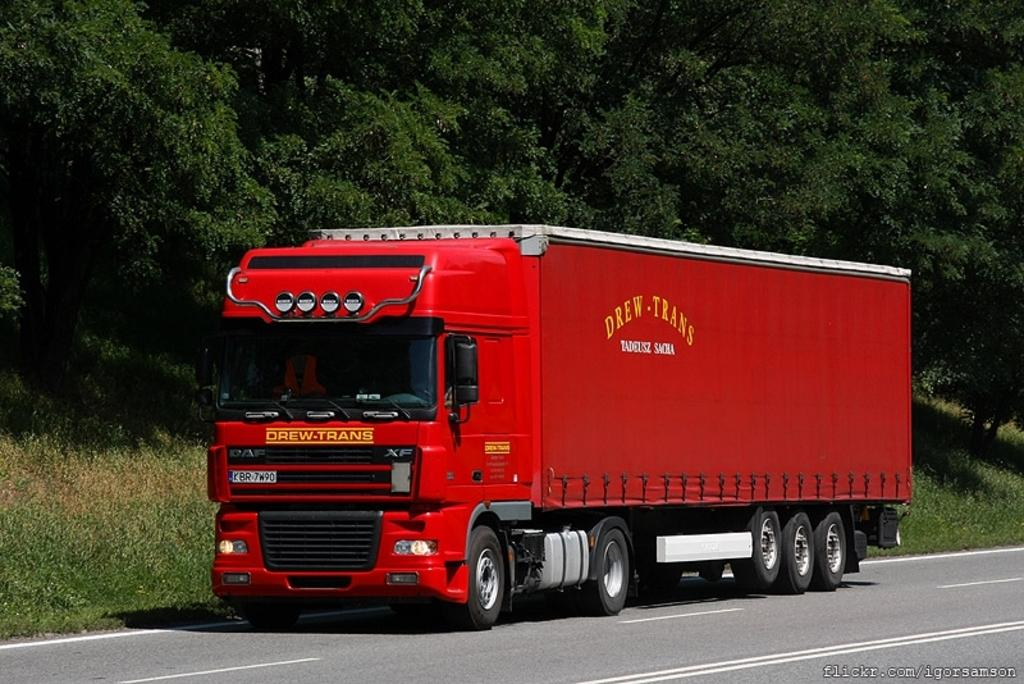What is the main subject in the center of the image? There is a vehicle in the center of the image. Where is the vehicle located? The vehicle is on the road. What can be seen in the background of the image? There are trees and grass visible in the background of the image. What month is it in the image? The month cannot be determined from the image, as there is no information about the time of year or specific date. 